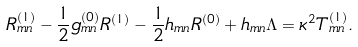Convert formula to latex. <formula><loc_0><loc_0><loc_500><loc_500>R ^ { ( 1 ) } _ { m n } - \frac { 1 } { 2 } g ^ { ( 0 ) } _ { m n } R ^ { ( 1 ) } - \frac { 1 } { 2 } h _ { m n } R ^ { ( 0 ) } + h _ { m n } \Lambda = \kappa ^ { 2 } T ^ { ( 1 ) } _ { m n } .</formula> 